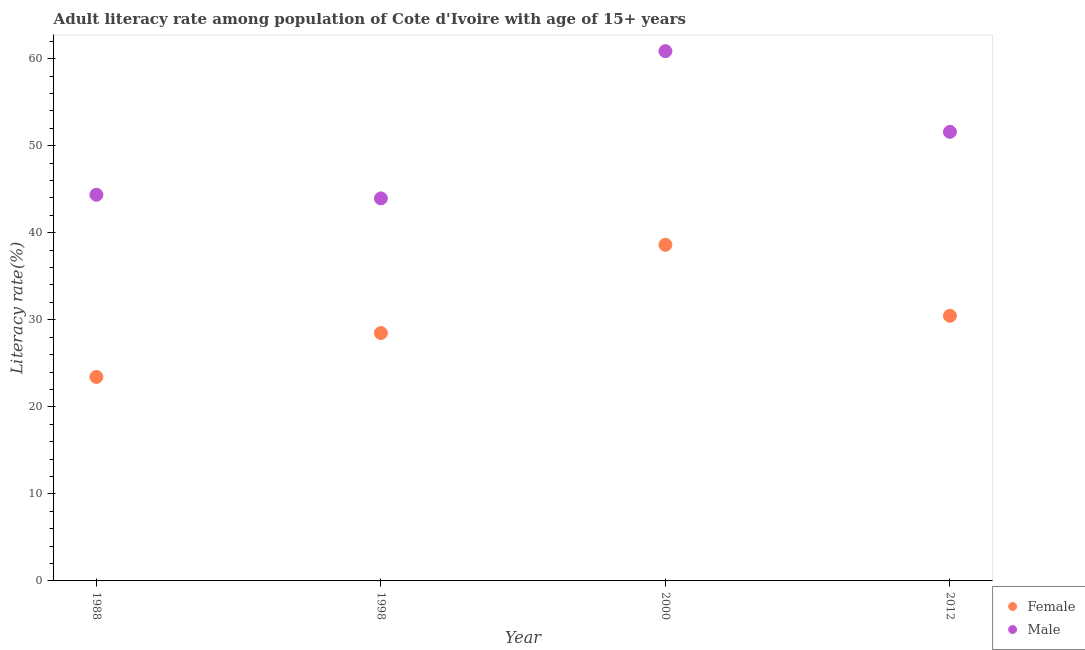How many different coloured dotlines are there?
Make the answer very short. 2. Is the number of dotlines equal to the number of legend labels?
Offer a very short reply. Yes. What is the female adult literacy rate in 1998?
Offer a very short reply. 28.48. Across all years, what is the maximum female adult literacy rate?
Give a very brief answer. 38.61. Across all years, what is the minimum female adult literacy rate?
Your response must be concise. 23.43. In which year was the male adult literacy rate maximum?
Keep it short and to the point. 2000. In which year was the male adult literacy rate minimum?
Offer a terse response. 1998. What is the total male adult literacy rate in the graph?
Your response must be concise. 200.76. What is the difference between the female adult literacy rate in 2000 and that in 2012?
Your response must be concise. 8.15. What is the difference between the female adult literacy rate in 1998 and the male adult literacy rate in 2000?
Your answer should be compact. -32.38. What is the average female adult literacy rate per year?
Give a very brief answer. 30.25. In the year 2012, what is the difference between the female adult literacy rate and male adult literacy rate?
Offer a terse response. -21.13. In how many years, is the male adult literacy rate greater than 52 %?
Make the answer very short. 1. What is the ratio of the male adult literacy rate in 1988 to that in 2012?
Your answer should be compact. 0.86. What is the difference between the highest and the second highest female adult literacy rate?
Make the answer very short. 8.15. What is the difference between the highest and the lowest male adult literacy rate?
Give a very brief answer. 16.91. In how many years, is the female adult literacy rate greater than the average female adult literacy rate taken over all years?
Keep it short and to the point. 2. Does the female adult literacy rate monotonically increase over the years?
Your answer should be very brief. No. Is the female adult literacy rate strictly greater than the male adult literacy rate over the years?
Give a very brief answer. No. Is the male adult literacy rate strictly less than the female adult literacy rate over the years?
Make the answer very short. No. Does the graph contain any zero values?
Provide a short and direct response. No. Does the graph contain grids?
Offer a very short reply. No. How many legend labels are there?
Provide a short and direct response. 2. How are the legend labels stacked?
Your answer should be very brief. Vertical. What is the title of the graph?
Your answer should be compact. Adult literacy rate among population of Cote d'Ivoire with age of 15+ years. What is the label or title of the X-axis?
Make the answer very short. Year. What is the label or title of the Y-axis?
Make the answer very short. Literacy rate(%). What is the Literacy rate(%) of Female in 1988?
Keep it short and to the point. 23.43. What is the Literacy rate(%) of Male in 1988?
Your response must be concise. 44.36. What is the Literacy rate(%) in Female in 1998?
Ensure brevity in your answer.  28.48. What is the Literacy rate(%) in Male in 1998?
Keep it short and to the point. 43.95. What is the Literacy rate(%) in Female in 2000?
Offer a very short reply. 38.61. What is the Literacy rate(%) in Male in 2000?
Ensure brevity in your answer.  60.86. What is the Literacy rate(%) of Female in 2012?
Offer a terse response. 30.46. What is the Literacy rate(%) in Male in 2012?
Provide a succinct answer. 51.59. Across all years, what is the maximum Literacy rate(%) of Female?
Offer a terse response. 38.61. Across all years, what is the maximum Literacy rate(%) of Male?
Offer a terse response. 60.86. Across all years, what is the minimum Literacy rate(%) of Female?
Your answer should be very brief. 23.43. Across all years, what is the minimum Literacy rate(%) in Male?
Make the answer very short. 43.95. What is the total Literacy rate(%) in Female in the graph?
Keep it short and to the point. 120.99. What is the total Literacy rate(%) in Male in the graph?
Your answer should be compact. 200.76. What is the difference between the Literacy rate(%) in Female in 1988 and that in 1998?
Your response must be concise. -5.04. What is the difference between the Literacy rate(%) in Male in 1988 and that in 1998?
Keep it short and to the point. 0.42. What is the difference between the Literacy rate(%) of Female in 1988 and that in 2000?
Offer a very short reply. -15.18. What is the difference between the Literacy rate(%) in Male in 1988 and that in 2000?
Your answer should be compact. -16.5. What is the difference between the Literacy rate(%) in Female in 1988 and that in 2012?
Your response must be concise. -7.03. What is the difference between the Literacy rate(%) in Male in 1988 and that in 2012?
Offer a terse response. -7.23. What is the difference between the Literacy rate(%) in Female in 1998 and that in 2000?
Your response must be concise. -10.14. What is the difference between the Literacy rate(%) in Male in 1998 and that in 2000?
Offer a terse response. -16.91. What is the difference between the Literacy rate(%) of Female in 1998 and that in 2012?
Give a very brief answer. -1.99. What is the difference between the Literacy rate(%) of Male in 1998 and that in 2012?
Your answer should be compact. -7.65. What is the difference between the Literacy rate(%) in Female in 2000 and that in 2012?
Offer a terse response. 8.15. What is the difference between the Literacy rate(%) of Male in 2000 and that in 2012?
Your response must be concise. 9.27. What is the difference between the Literacy rate(%) of Female in 1988 and the Literacy rate(%) of Male in 1998?
Make the answer very short. -20.51. What is the difference between the Literacy rate(%) in Female in 1988 and the Literacy rate(%) in Male in 2000?
Your response must be concise. -37.43. What is the difference between the Literacy rate(%) in Female in 1988 and the Literacy rate(%) in Male in 2012?
Offer a terse response. -28.16. What is the difference between the Literacy rate(%) of Female in 1998 and the Literacy rate(%) of Male in 2000?
Ensure brevity in your answer.  -32.38. What is the difference between the Literacy rate(%) in Female in 1998 and the Literacy rate(%) in Male in 2012?
Give a very brief answer. -23.12. What is the difference between the Literacy rate(%) of Female in 2000 and the Literacy rate(%) of Male in 2012?
Your answer should be very brief. -12.98. What is the average Literacy rate(%) of Female per year?
Provide a succinct answer. 30.25. What is the average Literacy rate(%) in Male per year?
Your response must be concise. 50.19. In the year 1988, what is the difference between the Literacy rate(%) of Female and Literacy rate(%) of Male?
Make the answer very short. -20.93. In the year 1998, what is the difference between the Literacy rate(%) of Female and Literacy rate(%) of Male?
Provide a succinct answer. -15.47. In the year 2000, what is the difference between the Literacy rate(%) of Female and Literacy rate(%) of Male?
Make the answer very short. -22.25. In the year 2012, what is the difference between the Literacy rate(%) of Female and Literacy rate(%) of Male?
Keep it short and to the point. -21.13. What is the ratio of the Literacy rate(%) of Female in 1988 to that in 1998?
Offer a terse response. 0.82. What is the ratio of the Literacy rate(%) in Male in 1988 to that in 1998?
Your answer should be very brief. 1.01. What is the ratio of the Literacy rate(%) in Female in 1988 to that in 2000?
Your answer should be very brief. 0.61. What is the ratio of the Literacy rate(%) of Male in 1988 to that in 2000?
Offer a terse response. 0.73. What is the ratio of the Literacy rate(%) in Female in 1988 to that in 2012?
Your answer should be very brief. 0.77. What is the ratio of the Literacy rate(%) of Male in 1988 to that in 2012?
Offer a very short reply. 0.86. What is the ratio of the Literacy rate(%) of Female in 1998 to that in 2000?
Provide a succinct answer. 0.74. What is the ratio of the Literacy rate(%) in Male in 1998 to that in 2000?
Your answer should be very brief. 0.72. What is the ratio of the Literacy rate(%) in Female in 1998 to that in 2012?
Keep it short and to the point. 0.93. What is the ratio of the Literacy rate(%) in Male in 1998 to that in 2012?
Give a very brief answer. 0.85. What is the ratio of the Literacy rate(%) in Female in 2000 to that in 2012?
Your answer should be very brief. 1.27. What is the ratio of the Literacy rate(%) in Male in 2000 to that in 2012?
Your answer should be very brief. 1.18. What is the difference between the highest and the second highest Literacy rate(%) of Female?
Ensure brevity in your answer.  8.15. What is the difference between the highest and the second highest Literacy rate(%) of Male?
Offer a terse response. 9.27. What is the difference between the highest and the lowest Literacy rate(%) of Female?
Ensure brevity in your answer.  15.18. What is the difference between the highest and the lowest Literacy rate(%) in Male?
Your answer should be very brief. 16.91. 